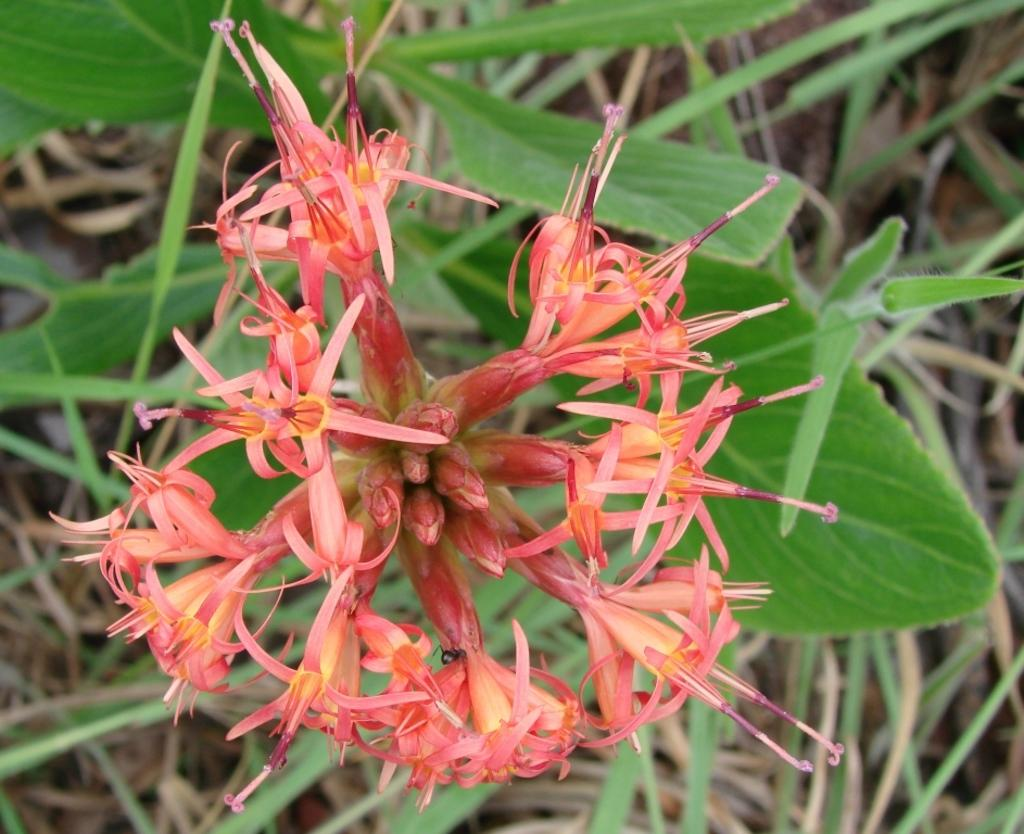What type of plant life can be seen in the image? There are flowers and leaves in the image. Can you describe the flowers in the image? Unfortunately, the facts provided do not give specific details about the flowers. What is the color of the leaves in the image? The facts provided do not specify the color of the leaves. What type of vegetable is being chopped on the channel in the image? There is no channel or vegetable present in the image; it features flowers and leaves. How many feet are visible in the image? There are no feet present in the image. 